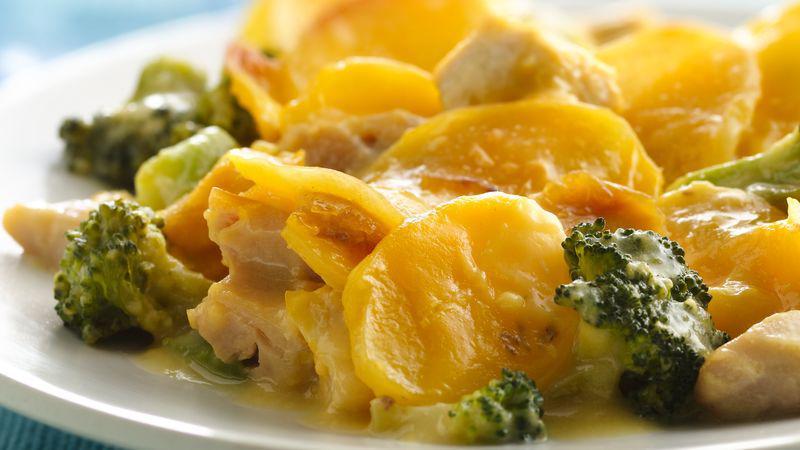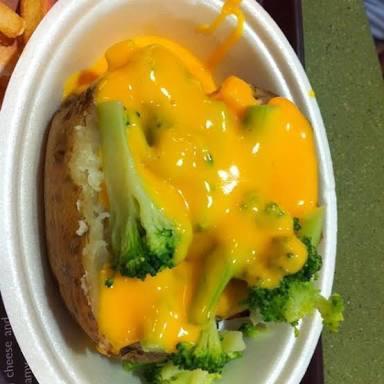The first image is the image on the left, the second image is the image on the right. Considering the images on both sides, is "Both images show food served on an all-white dish." valid? Answer yes or no. Yes. The first image is the image on the left, the second image is the image on the right. For the images displayed, is the sentence "The food is one a white plate in the image on the left." factually correct? Answer yes or no. Yes. 